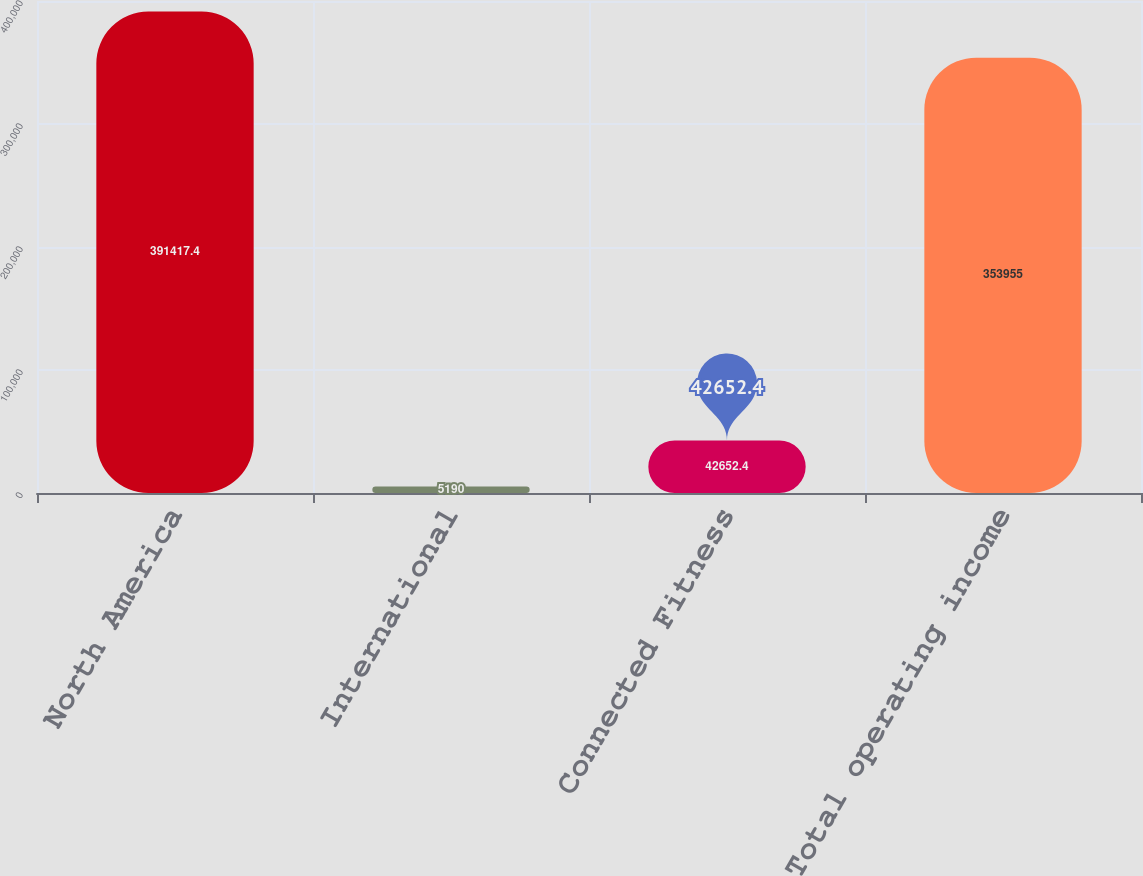Convert chart to OTSL. <chart><loc_0><loc_0><loc_500><loc_500><bar_chart><fcel>North America<fcel>International<fcel>Connected Fitness<fcel>Total operating income<nl><fcel>391417<fcel>5190<fcel>42652.4<fcel>353955<nl></chart> 